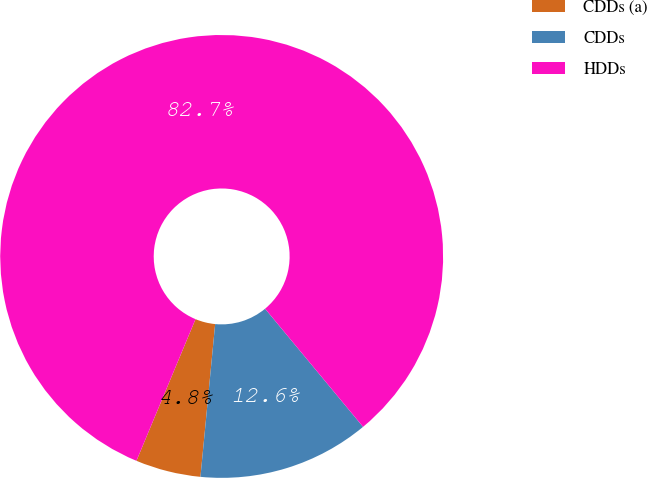<chart> <loc_0><loc_0><loc_500><loc_500><pie_chart><fcel>CDDs (a)<fcel>CDDs<fcel>HDDs<nl><fcel>4.76%<fcel>12.55%<fcel>82.69%<nl></chart> 